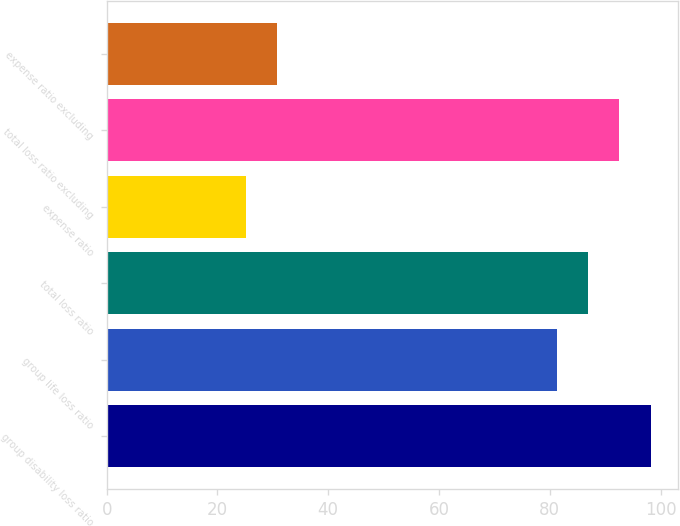Convert chart. <chart><loc_0><loc_0><loc_500><loc_500><bar_chart><fcel>group disability loss ratio<fcel>group life loss ratio<fcel>total loss ratio<fcel>expense ratio<fcel>total loss ratio excluding<fcel>expense ratio excluding<nl><fcel>98.22<fcel>81.33<fcel>86.96<fcel>25.1<fcel>92.59<fcel>30.73<nl></chart> 